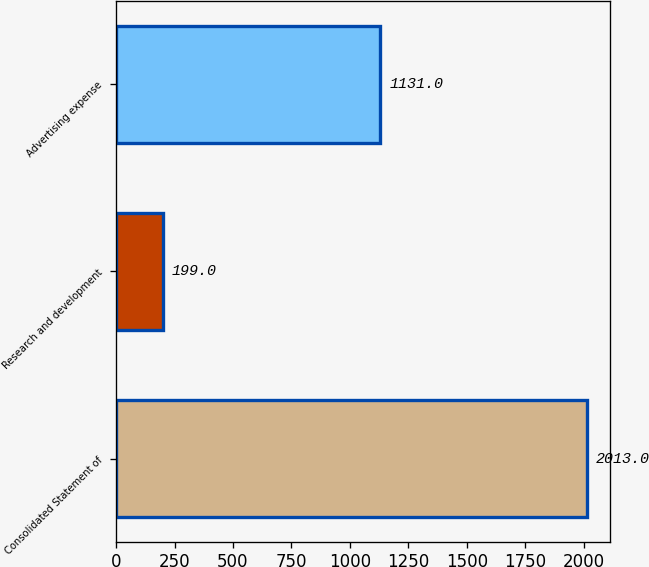Convert chart. <chart><loc_0><loc_0><loc_500><loc_500><bar_chart><fcel>Consolidated Statement of<fcel>Research and development<fcel>Advertising expense<nl><fcel>2013<fcel>199<fcel>1131<nl></chart> 